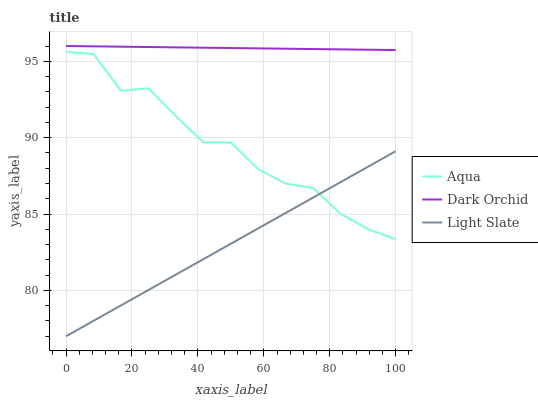Does Light Slate have the minimum area under the curve?
Answer yes or no. Yes. Does Dark Orchid have the maximum area under the curve?
Answer yes or no. Yes. Does Aqua have the minimum area under the curve?
Answer yes or no. No. Does Aqua have the maximum area under the curve?
Answer yes or no. No. Is Dark Orchid the smoothest?
Answer yes or no. Yes. Is Aqua the roughest?
Answer yes or no. Yes. Is Aqua the smoothest?
Answer yes or no. No. Is Dark Orchid the roughest?
Answer yes or no. No. Does Light Slate have the lowest value?
Answer yes or no. Yes. Does Aqua have the lowest value?
Answer yes or no. No. Does Dark Orchid have the highest value?
Answer yes or no. Yes. Does Aqua have the highest value?
Answer yes or no. No. Is Light Slate less than Dark Orchid?
Answer yes or no. Yes. Is Dark Orchid greater than Light Slate?
Answer yes or no. Yes. Does Aqua intersect Light Slate?
Answer yes or no. Yes. Is Aqua less than Light Slate?
Answer yes or no. No. Is Aqua greater than Light Slate?
Answer yes or no. No. Does Light Slate intersect Dark Orchid?
Answer yes or no. No. 